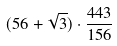Convert formula to latex. <formula><loc_0><loc_0><loc_500><loc_500>( 5 6 + \sqrt { 3 } ) \cdot \frac { 4 4 3 } { 1 5 6 }</formula> 